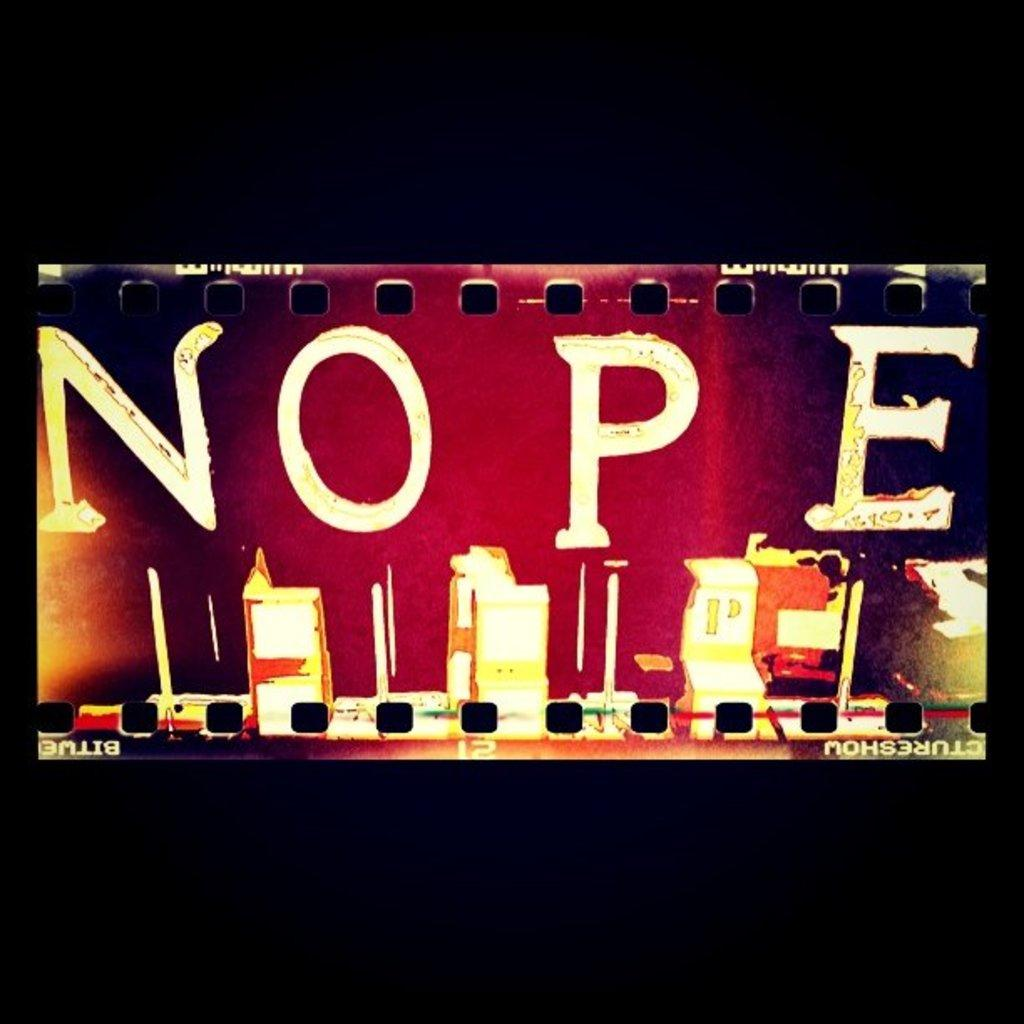<image>
Render a clear and concise summary of the photo. Large light up sign that has the word NOPE on it. 